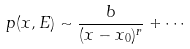Convert formula to latex. <formula><loc_0><loc_0><loc_500><loc_500>p ( x , E ) \sim \frac { b } { ( x - x _ { 0 } ) ^ { r } } + \cdots</formula> 